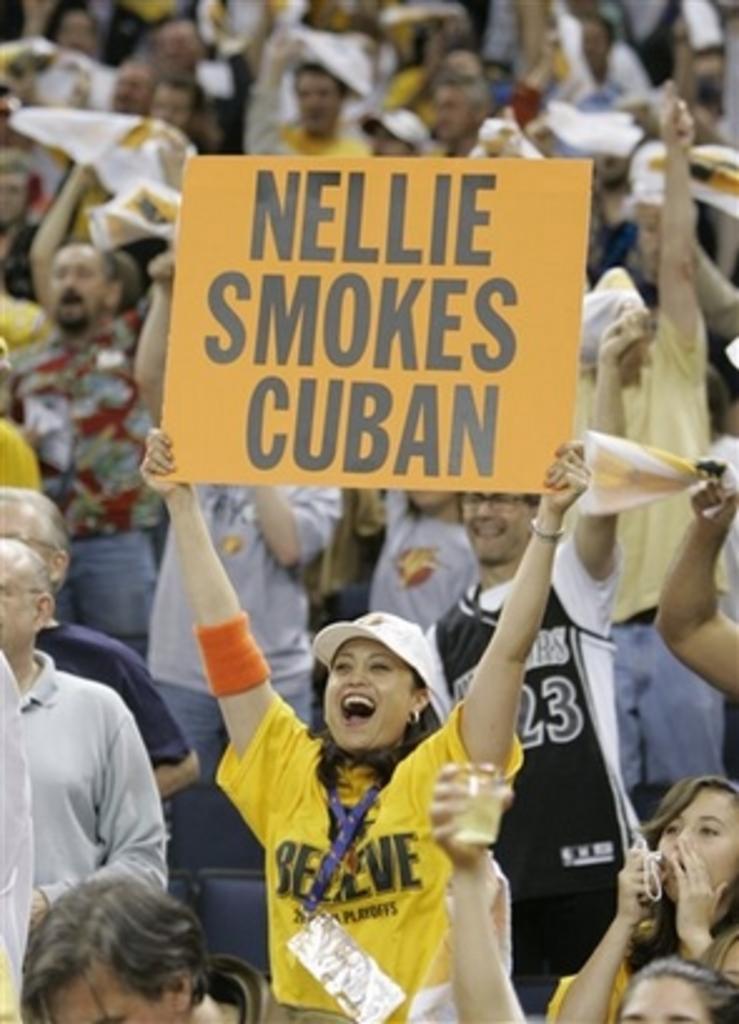Can you describe this image briefly? In this image I can see a woman holding a board with some text written on it. In the background, I can see some other people. 